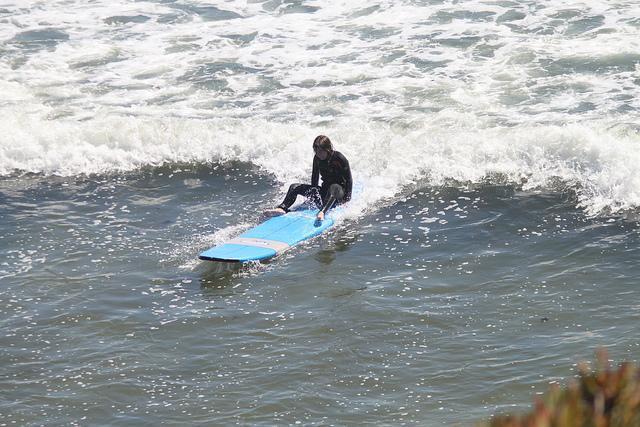How many surfers are there?
Give a very brief answer. 1. How many hot dogs will this person be eating?
Give a very brief answer. 0. 